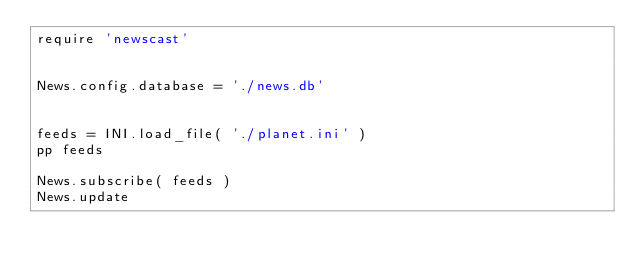Convert code to text. <code><loc_0><loc_0><loc_500><loc_500><_Ruby_>require 'newscast'


News.config.database = './news.db'


feeds = INI.load_file( './planet.ini' )
pp feeds

News.subscribe( feeds )
News.update
</code> 